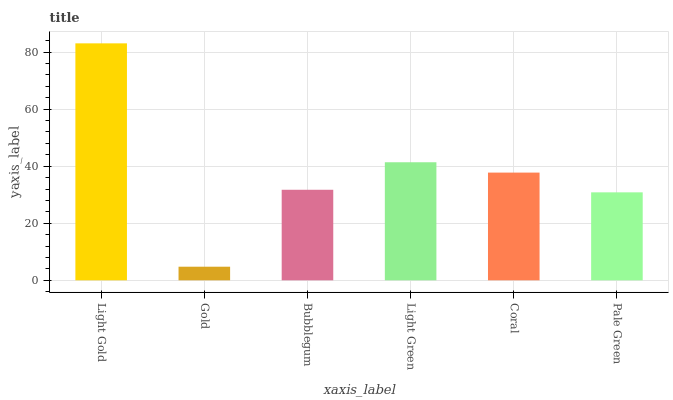Is Bubblegum the minimum?
Answer yes or no. No. Is Bubblegum the maximum?
Answer yes or no. No. Is Bubblegum greater than Gold?
Answer yes or no. Yes. Is Gold less than Bubblegum?
Answer yes or no. Yes. Is Gold greater than Bubblegum?
Answer yes or no. No. Is Bubblegum less than Gold?
Answer yes or no. No. Is Coral the high median?
Answer yes or no. Yes. Is Bubblegum the low median?
Answer yes or no. Yes. Is Light Gold the high median?
Answer yes or no. No. Is Light Gold the low median?
Answer yes or no. No. 